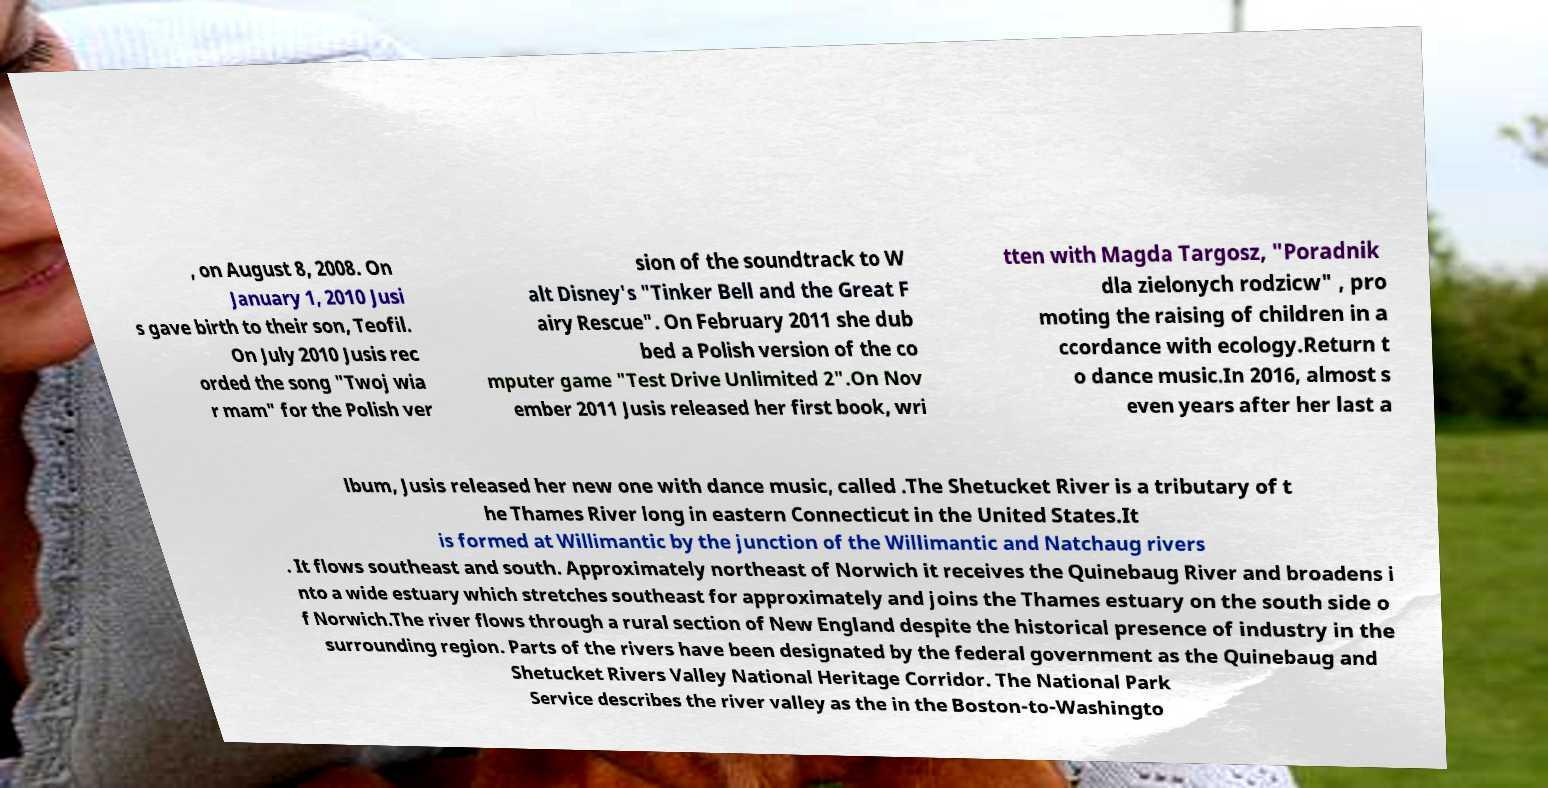Could you assist in decoding the text presented in this image and type it out clearly? , on August 8, 2008. On January 1, 2010 Jusi s gave birth to their son, Teofil. On July 2010 Jusis rec orded the song "Twoj wia r mam" for the Polish ver sion of the soundtrack to W alt Disney's "Tinker Bell and the Great F airy Rescue". On February 2011 she dub bed a Polish version of the co mputer game "Test Drive Unlimited 2".On Nov ember 2011 Jusis released her first book, wri tten with Magda Targosz, "Poradnik dla zielonych rodzicw" , pro moting the raising of children in a ccordance with ecology.Return t o dance music.In 2016, almost s even years after her last a lbum, Jusis released her new one with dance music, called .The Shetucket River is a tributary of t he Thames River long in eastern Connecticut in the United States.It is formed at Willimantic by the junction of the Willimantic and Natchaug rivers . It flows southeast and south. Approximately northeast of Norwich it receives the Quinebaug River and broadens i nto a wide estuary which stretches southeast for approximately and joins the Thames estuary on the south side o f Norwich.The river flows through a rural section of New England despite the historical presence of industry in the surrounding region. Parts of the rivers have been designated by the federal government as the Quinebaug and Shetucket Rivers Valley National Heritage Corridor. The National Park Service describes the river valley as the in the Boston-to-Washingto 